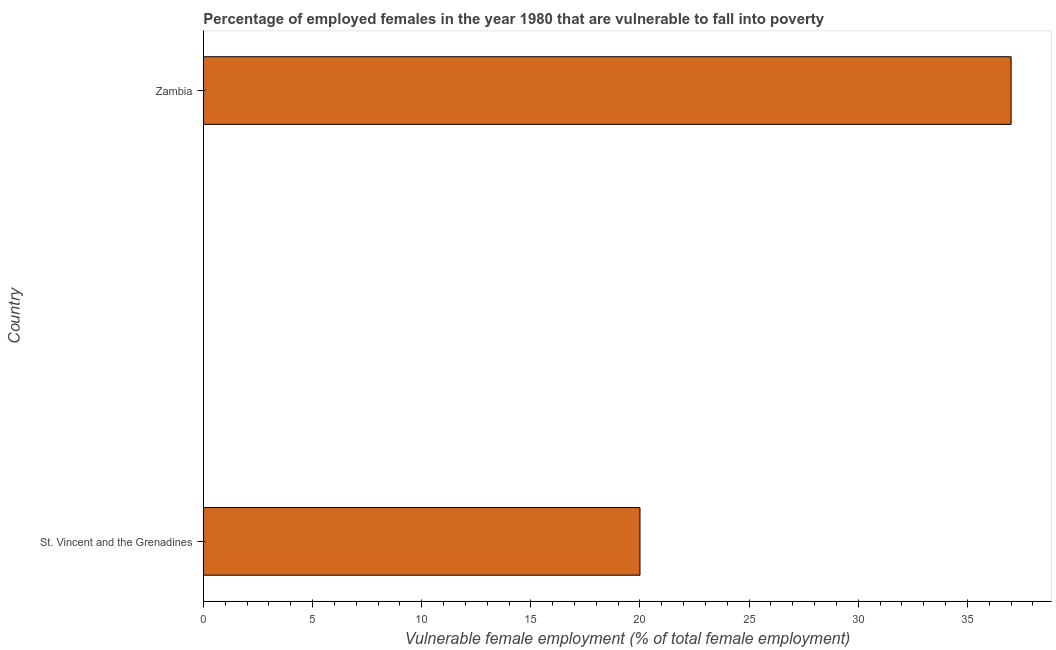Does the graph contain any zero values?
Offer a terse response. No. Does the graph contain grids?
Make the answer very short. No. What is the title of the graph?
Your answer should be very brief. Percentage of employed females in the year 1980 that are vulnerable to fall into poverty. What is the label or title of the X-axis?
Provide a short and direct response. Vulnerable female employment (% of total female employment). What is the percentage of employed females who are vulnerable to fall into poverty in St. Vincent and the Grenadines?
Your response must be concise. 20. Across all countries, what is the minimum percentage of employed females who are vulnerable to fall into poverty?
Your response must be concise. 20. In which country was the percentage of employed females who are vulnerable to fall into poverty maximum?
Provide a short and direct response. Zambia. In which country was the percentage of employed females who are vulnerable to fall into poverty minimum?
Offer a very short reply. St. Vincent and the Grenadines. What is the median percentage of employed females who are vulnerable to fall into poverty?
Give a very brief answer. 28.5. In how many countries, is the percentage of employed females who are vulnerable to fall into poverty greater than 23 %?
Offer a very short reply. 1. What is the ratio of the percentage of employed females who are vulnerable to fall into poverty in St. Vincent and the Grenadines to that in Zambia?
Offer a very short reply. 0.54. In how many countries, is the percentage of employed females who are vulnerable to fall into poverty greater than the average percentage of employed females who are vulnerable to fall into poverty taken over all countries?
Keep it short and to the point. 1. How many bars are there?
Your response must be concise. 2. Are all the bars in the graph horizontal?
Make the answer very short. Yes. What is the difference between two consecutive major ticks on the X-axis?
Make the answer very short. 5. Are the values on the major ticks of X-axis written in scientific E-notation?
Offer a very short reply. No. What is the Vulnerable female employment (% of total female employment) in Zambia?
Offer a terse response. 37. What is the ratio of the Vulnerable female employment (% of total female employment) in St. Vincent and the Grenadines to that in Zambia?
Offer a very short reply. 0.54. 